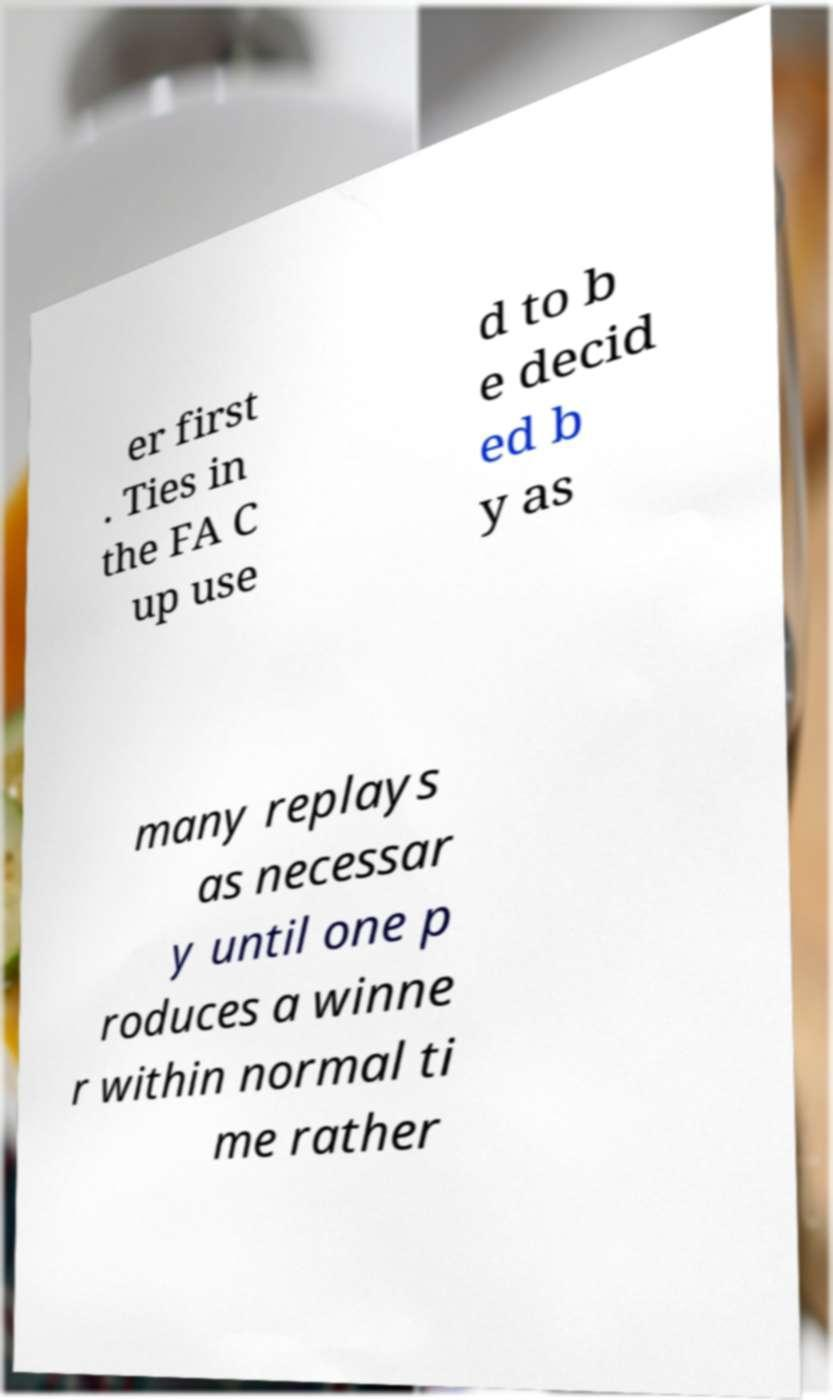For documentation purposes, I need the text within this image transcribed. Could you provide that? er first . Ties in the FA C up use d to b e decid ed b y as many replays as necessar y until one p roduces a winne r within normal ti me rather 